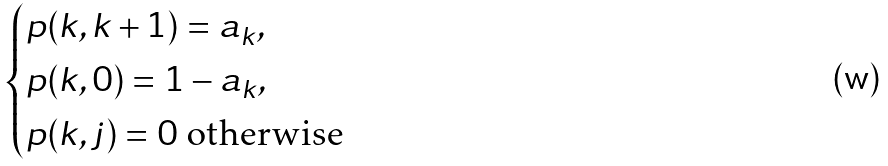Convert formula to latex. <formula><loc_0><loc_0><loc_500><loc_500>\begin{cases} p ( k , k + 1 ) = a _ { k } , \\ p ( k , 0 ) = 1 - a _ { k } , \\ p ( k , j ) = 0 \text { otherwise} \end{cases}</formula> 